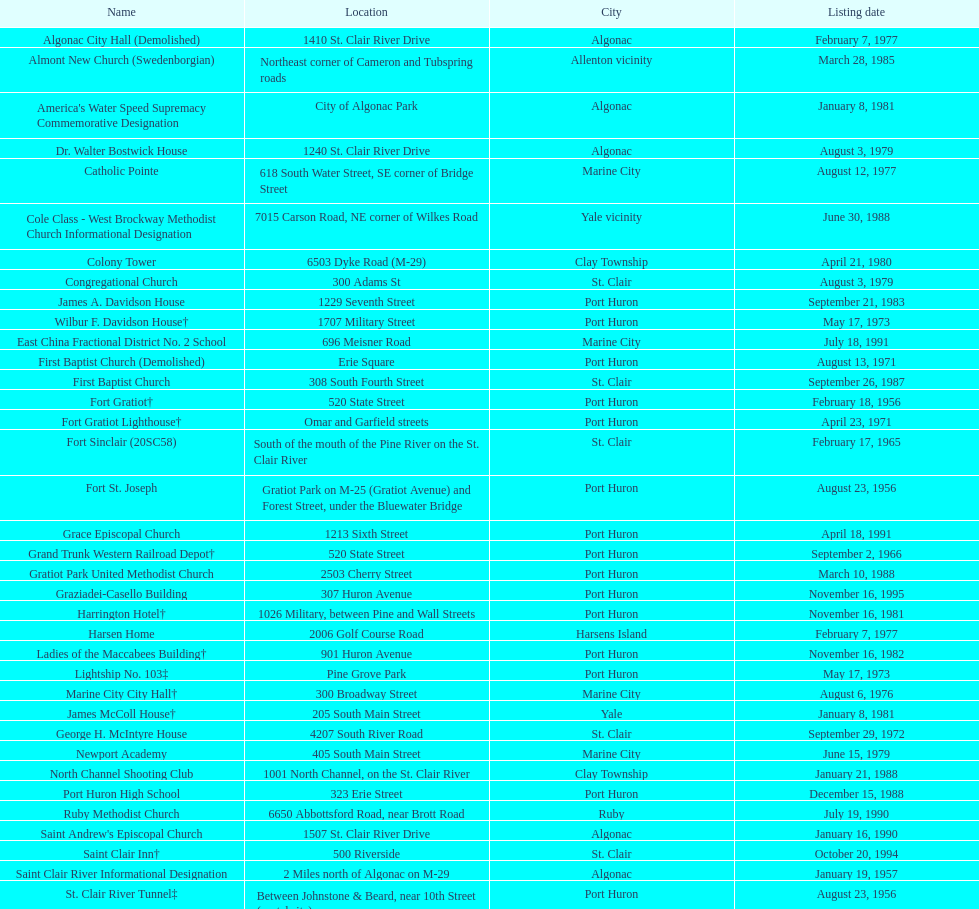Which city is home to the greatest number of historic sites, existing or demolished? Port Huron. 